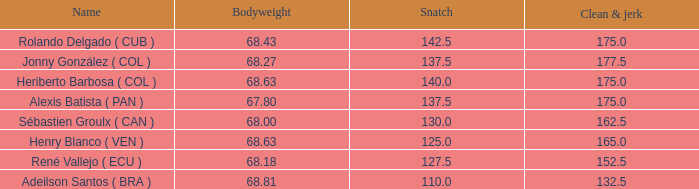Inform me of the overall count of snatches exceeding 13 1.0. 